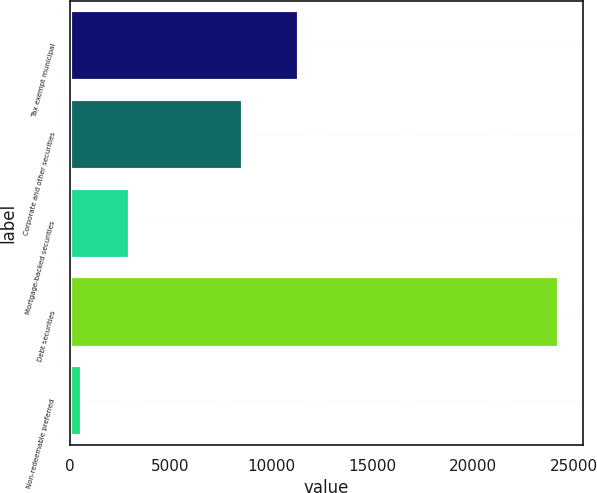Convert chart. <chart><loc_0><loc_0><loc_500><loc_500><bar_chart><fcel>Tax exempt municipal<fcel>Corporate and other securities<fcel>Mortgage-backed securities<fcel>Debt securities<fcel>Non-redeemable preferred<nl><fcel>11379<fcel>8593<fcel>2983.7<fcel>24248<fcel>621<nl></chart> 